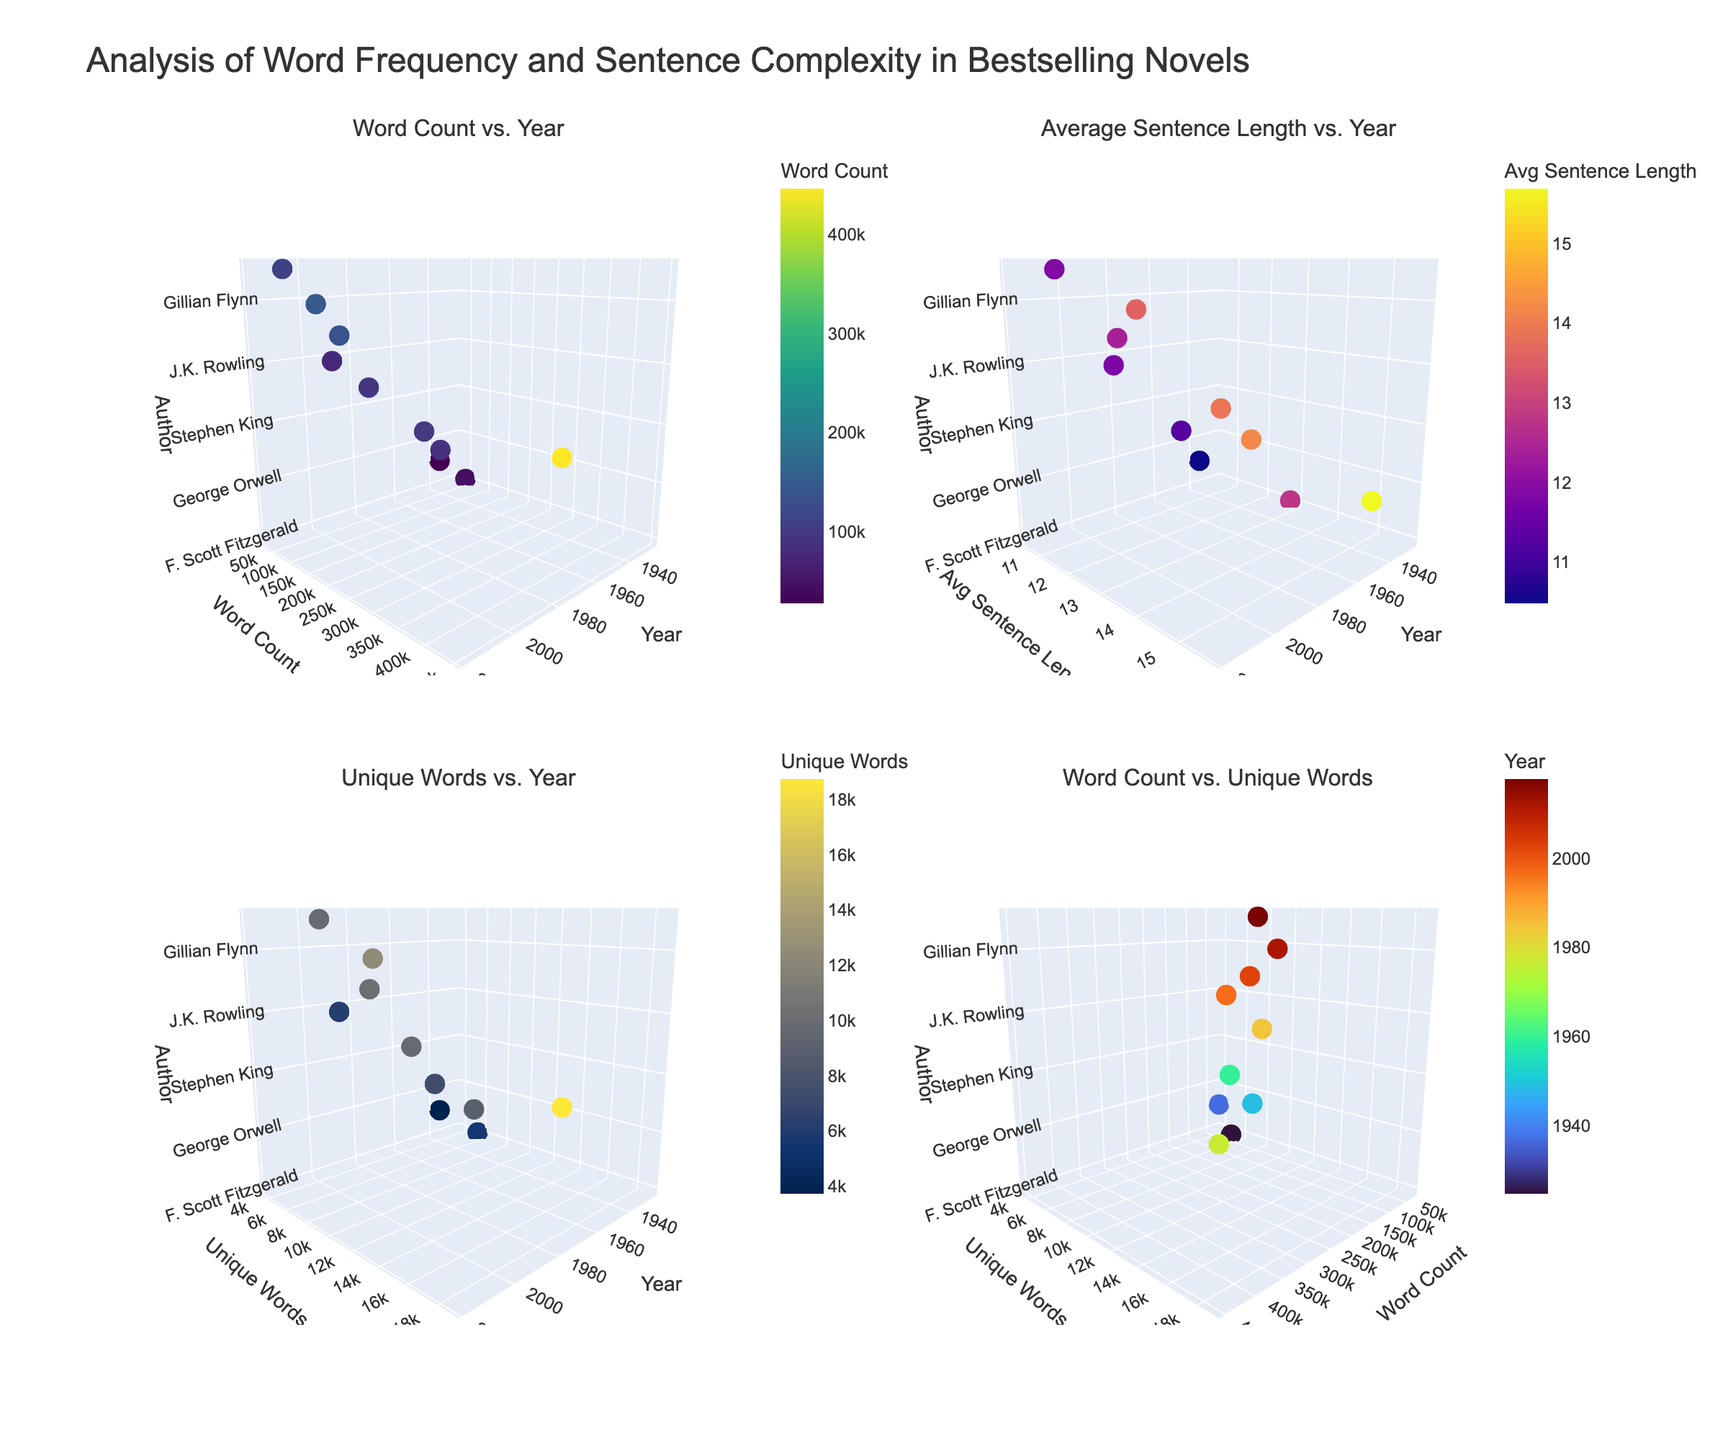What is the title of the figure? The title is displayed at the top of the figure, which reads "Analysis of Word Frequency and Sentence Complexity in Bestselling Novels."
Answer: Analysis of Word Frequency and Sentence Complexity in Bestselling Novels How many subplots are there in the figure? The layout shows four distinct subplots identified by the individual titles within each quadranton
Answer: Four Which subplot shows the number of unique words over the years? In the second row, first column, the subplot is titled "Unique Words vs. Year," showing the trend of unique words over the years.
Answer: Unique Words vs. Year Which author wrote the novel with the highest word count, and what year was it published? In the first subplot titled "Word Count vs. Year," the highest point on the y-axis corresponds to the highest word count. This point is linked with Stephen King in 1977.
Answer: Stephen King, 1977 Between "The Great Gatsby" and "1984," which novel has a higher average sentence length? Referring to the subplot "Average Sentence Length vs. Year," compare the z-axis values of "F. Scott Fitzgerald" and "George Orwell." George Orwell has a higher value.
Answer: 1984 What is the relationship between word count and unique words, and which novel has the highest unique words count? The fourth subplot titled "Word Count vs. Unique Words" indicates the relationship, showing that “The Shining” has the highest count. Checking the extremity on the y-axis confirms this.
Answer: The Shining For novels published in the 2000s, what common trend can be observed across all subplots? By analyzing the scatter patterns for data points from 2000s' plots across the subplots, the observation is fewer more balanced points as compared to earlier publications, indicating a balanced vocabulary variety and sentence complexity.
Answer: Balanced vocabulary and sentence complexity Which novel appears to have both a very high word count and unique word count? In the subplot "Word Count vs. Unique Words,” identify the data point that is high on both x and y-axes, attributed to Gillian Flynn's "Gone Girl."
Answer: Gone Girl Is there a noticeable trend in average sentence length over the years? In the "Average Sentence Length vs. Year" subplot, observe the z-axis pattern over time. There is no clear rising or falling trend visible; various lengths scatter throughout the years.
Answer: No noticeable trend 